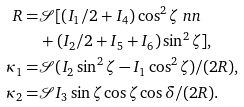Convert formula to latex. <formula><loc_0><loc_0><loc_500><loc_500>R = & \mathcal { S } [ ( I _ { 1 } / 2 + I _ { 4 } ) \cos ^ { 2 } \zeta \ n n \\ & + ( I _ { 2 } / 2 + I _ { 5 } + I _ { 6 } ) \sin ^ { 2 } \zeta ] , \\ \kappa _ { 1 } = & \mathcal { S } ( I _ { 2 } \sin ^ { 2 } \zeta - I _ { 1 } \cos ^ { 2 } \zeta ) / ( 2 R ) , \\ \kappa _ { 2 } = & \mathcal { S } I _ { 3 } \sin \zeta \cos \zeta \cos \delta / ( 2 R ) .</formula> 